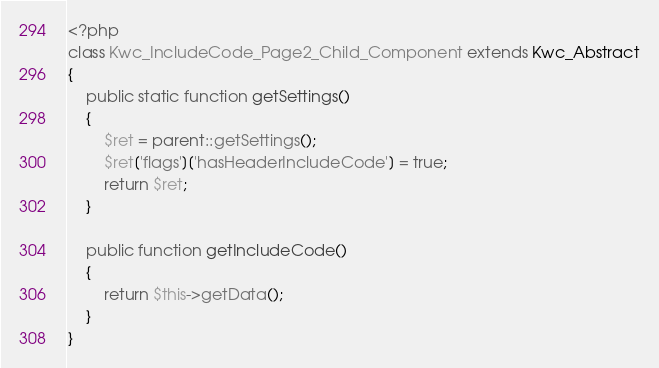Convert code to text. <code><loc_0><loc_0><loc_500><loc_500><_PHP_><?php
class Kwc_IncludeCode_Page2_Child_Component extends Kwc_Abstract
{
    public static function getSettings()
    {
        $ret = parent::getSettings();
        $ret['flags']['hasHeaderIncludeCode'] = true;
        return $ret;
    }

    public function getIncludeCode()
    {
        return $this->getData();
    }
}
</code> 